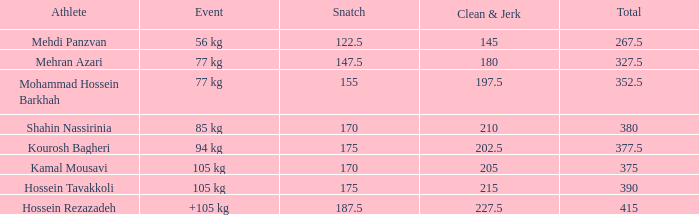5? 0.0. Can you parse all the data within this table? {'header': ['Athlete', 'Event', 'Snatch', 'Clean & Jerk', 'Total'], 'rows': [['Mehdi Panzvan', '56 kg', '122.5', '145', '267.5'], ['Mehran Azari', '77 kg', '147.5', '180', '327.5'], ['Mohammad Hossein Barkhah', '77 kg', '155', '197.5', '352.5'], ['Shahin Nassirinia', '85 kg', '170', '210', '380'], ['Kourosh Bagheri', '94 kg', '175', '202.5', '377.5'], ['Kamal Mousavi', '105 kg', '170', '205', '375'], ['Hossein Tavakkoli', '105 kg', '175', '215', '390'], ['Hossein Rezazadeh', '+105 kg', '187.5', '227.5', '415']]} 